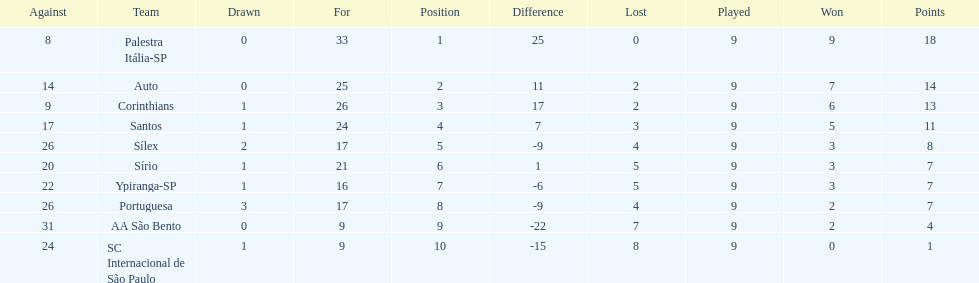Which team was the only team that was undefeated? Palestra Itália-SP. 